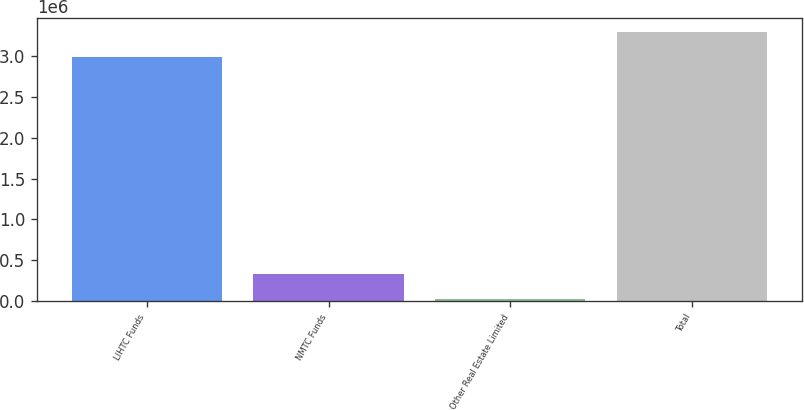Convert chart. <chart><loc_0><loc_0><loc_500><loc_500><bar_chart><fcel>LIHTC Funds<fcel>NMTC Funds<fcel>Other Real Estate Limited<fcel>Total<nl><fcel>2.98822e+06<fcel>337372<fcel>30202<fcel>3.29539e+06<nl></chart> 